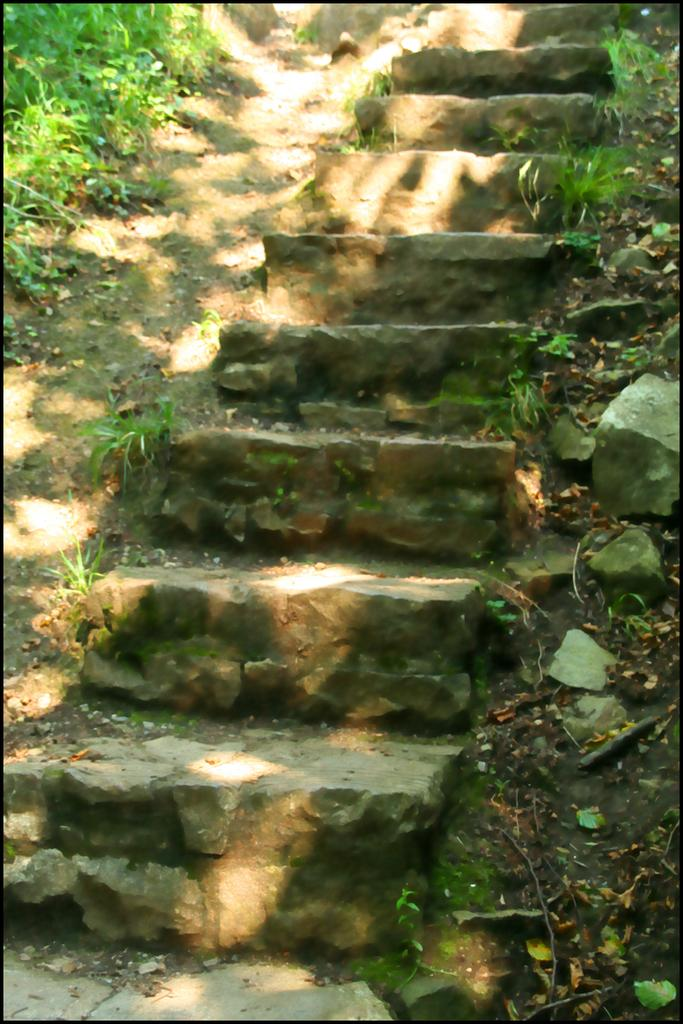What type of structure is visible in the image? There are steps in the image. What material are the steps made of? The steps are made up of stones. What type of vegetation is present around the steps? There is grass around the steps. What is the volume of the voice coming from the steps in the image? There is no voice present in the image; it only features steps made up of stones and grass around them. 